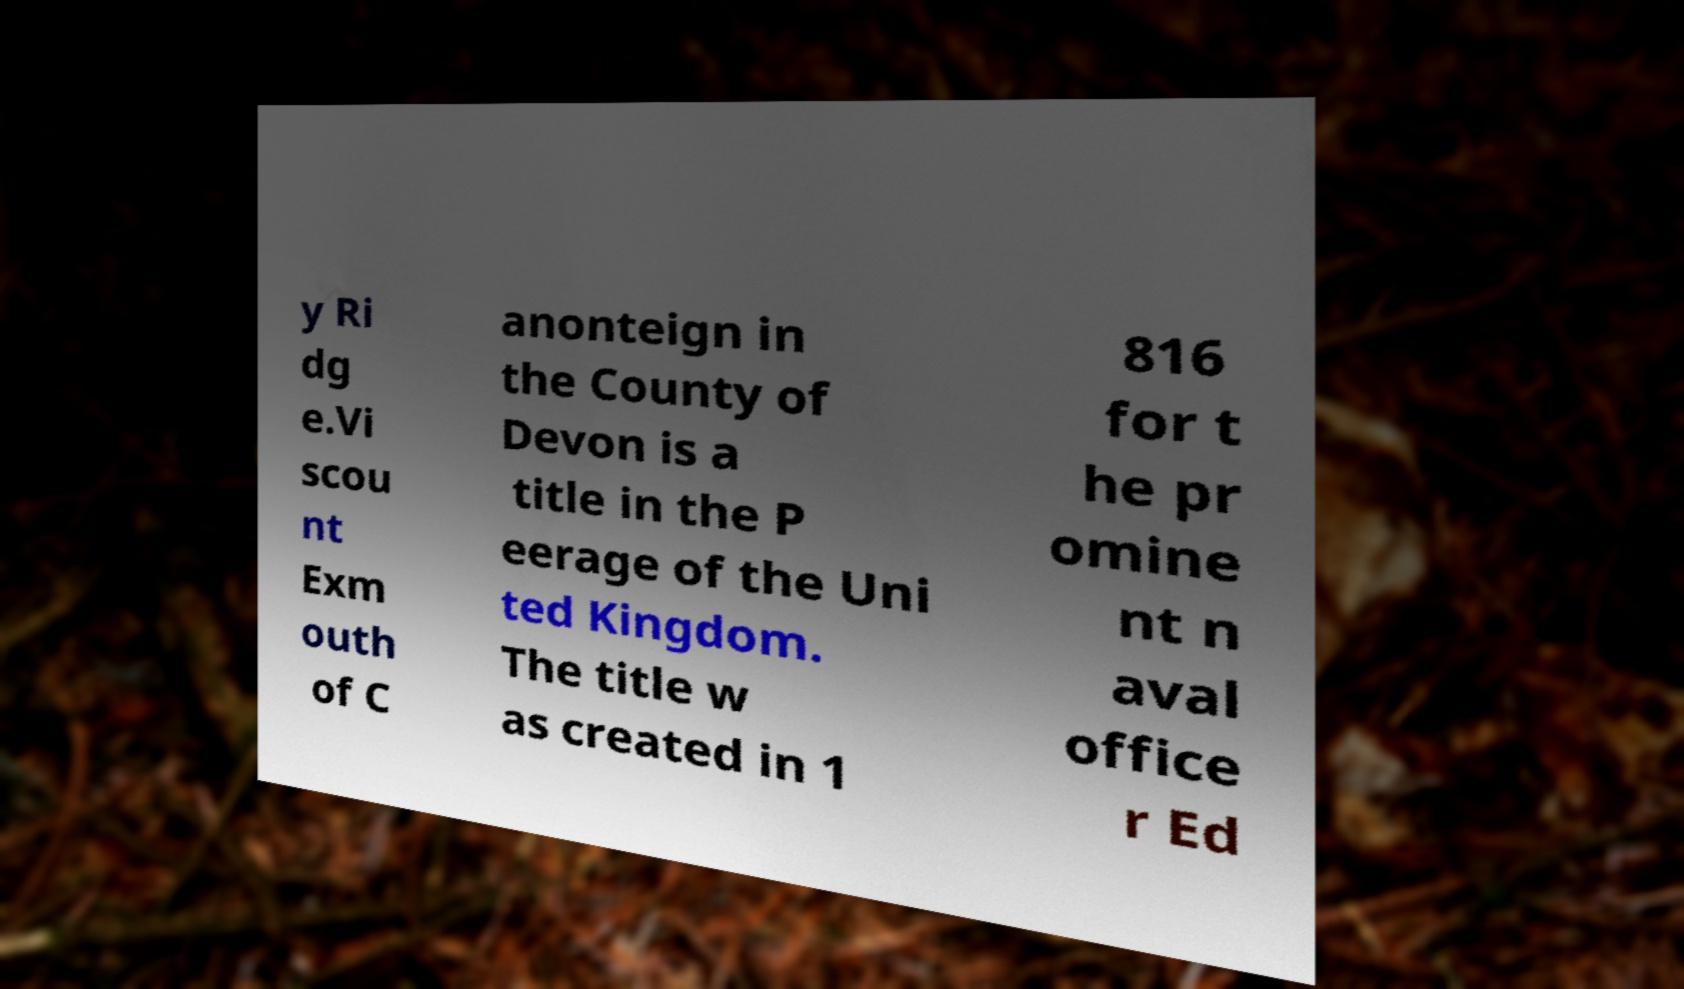Please read and relay the text visible in this image. What does it say? y Ri dg e.Vi scou nt Exm outh of C anonteign in the County of Devon is a title in the P eerage of the Uni ted Kingdom. The title w as created in 1 816 for t he pr omine nt n aval office r Ed 